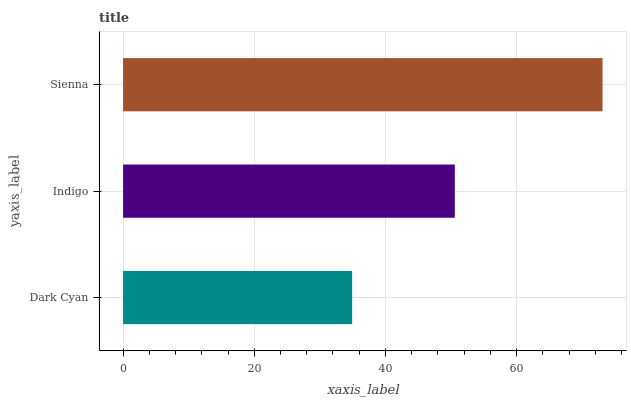Is Dark Cyan the minimum?
Answer yes or no. Yes. Is Sienna the maximum?
Answer yes or no. Yes. Is Indigo the minimum?
Answer yes or no. No. Is Indigo the maximum?
Answer yes or no. No. Is Indigo greater than Dark Cyan?
Answer yes or no. Yes. Is Dark Cyan less than Indigo?
Answer yes or no. Yes. Is Dark Cyan greater than Indigo?
Answer yes or no. No. Is Indigo less than Dark Cyan?
Answer yes or no. No. Is Indigo the high median?
Answer yes or no. Yes. Is Indigo the low median?
Answer yes or no. Yes. Is Sienna the high median?
Answer yes or no. No. Is Sienna the low median?
Answer yes or no. No. 